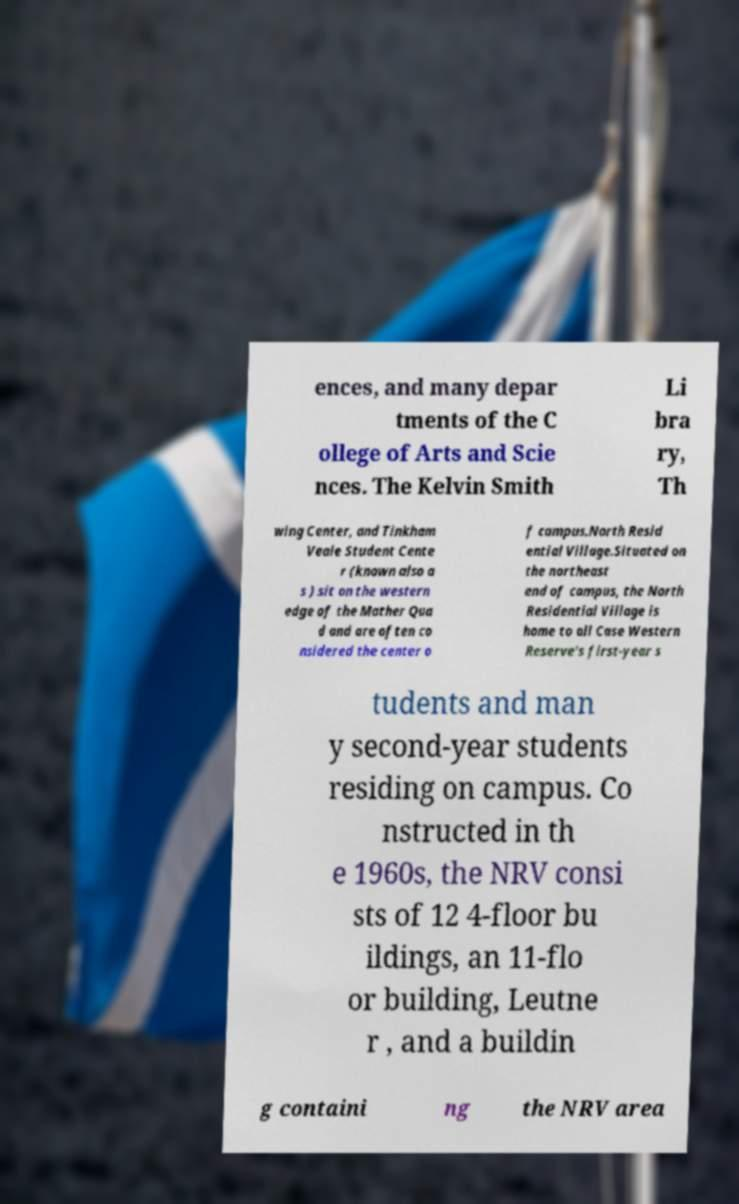Could you extract and type out the text from this image? ences, and many depar tments of the C ollege of Arts and Scie nces. The Kelvin Smith Li bra ry, Th wing Center, and Tinkham Veale Student Cente r (known also a s ) sit on the western edge of the Mather Qua d and are often co nsidered the center o f campus.North Resid ential Village.Situated on the northeast end of campus, the North Residential Village is home to all Case Western Reserve's first-year s tudents and man y second-year students residing on campus. Co nstructed in th e 1960s, the NRV consi sts of 12 4-floor bu ildings, an 11-flo or building, Leutne r , and a buildin g containi ng the NRV area 